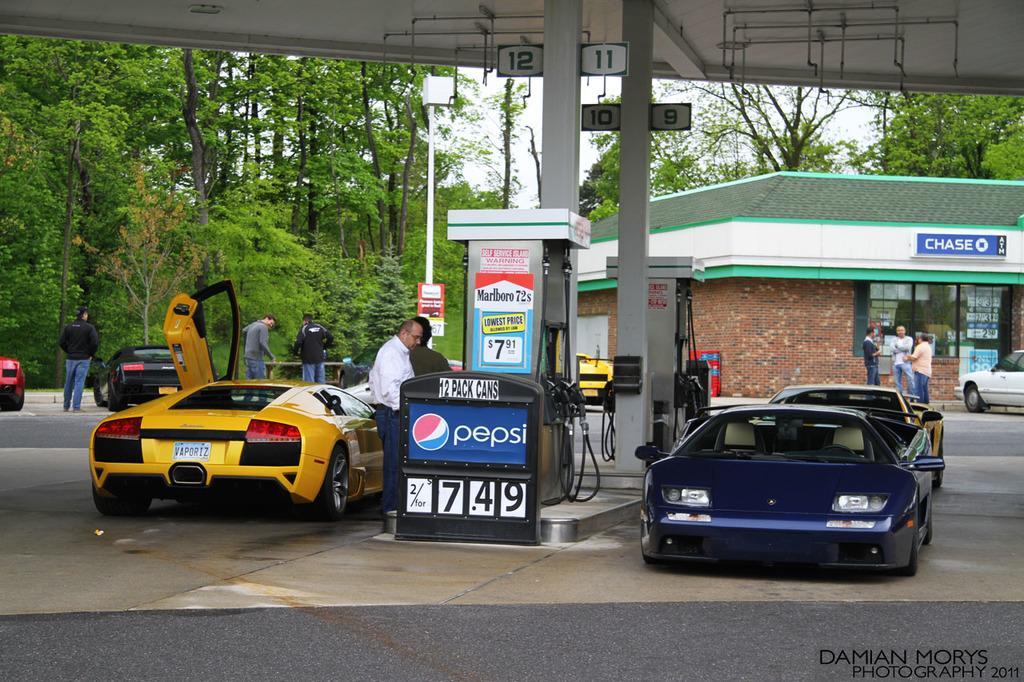Please provide a concise description of this image. In this image I can see petrol pump up under the pump I can see vehicles and persons filling pipes, on the right side I can see the house visible on the right side, in front of the house I can see persons and vehicles at the top I can see trees and I can see persons and pole in the middle 